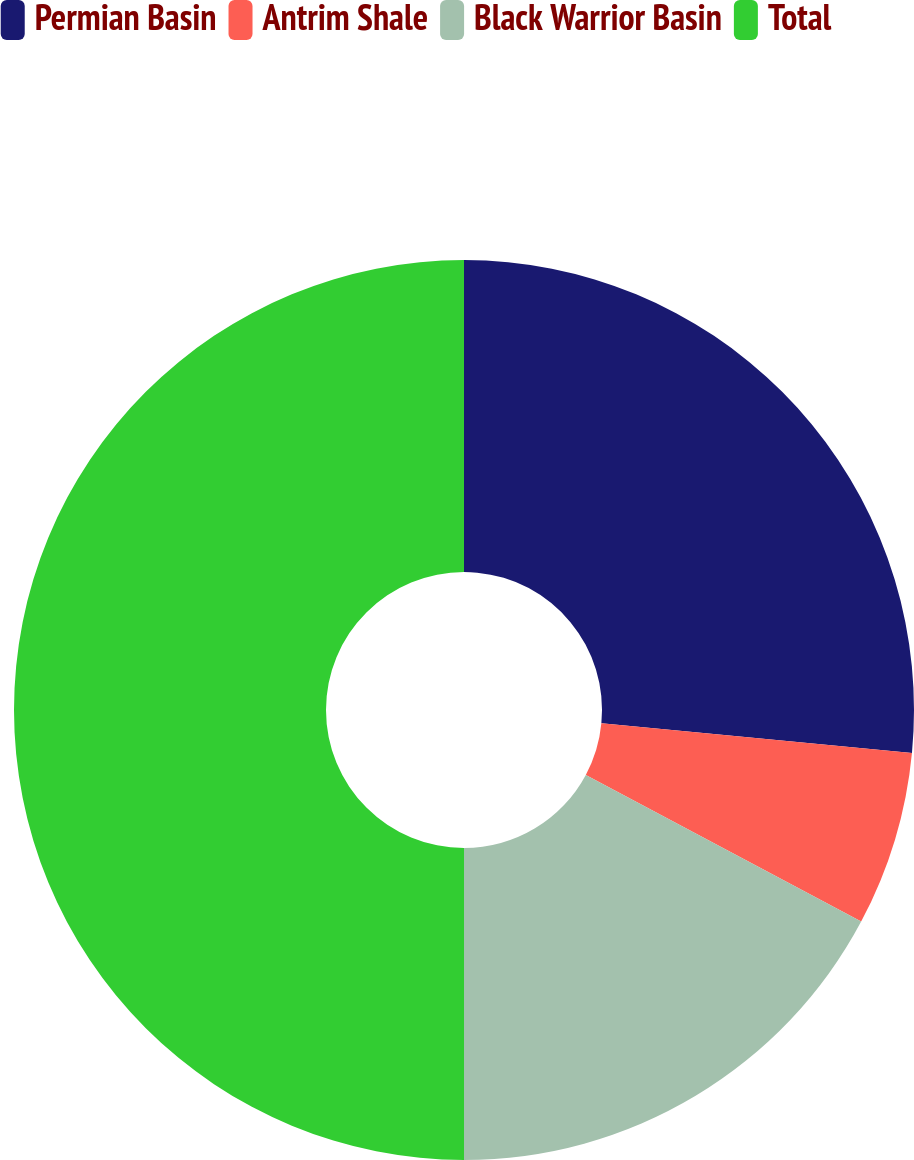<chart> <loc_0><loc_0><loc_500><loc_500><pie_chart><fcel>Permian Basin<fcel>Antrim Shale<fcel>Black Warrior Basin<fcel>Total<nl><fcel>26.52%<fcel>6.27%<fcel>17.21%<fcel>50.0%<nl></chart> 